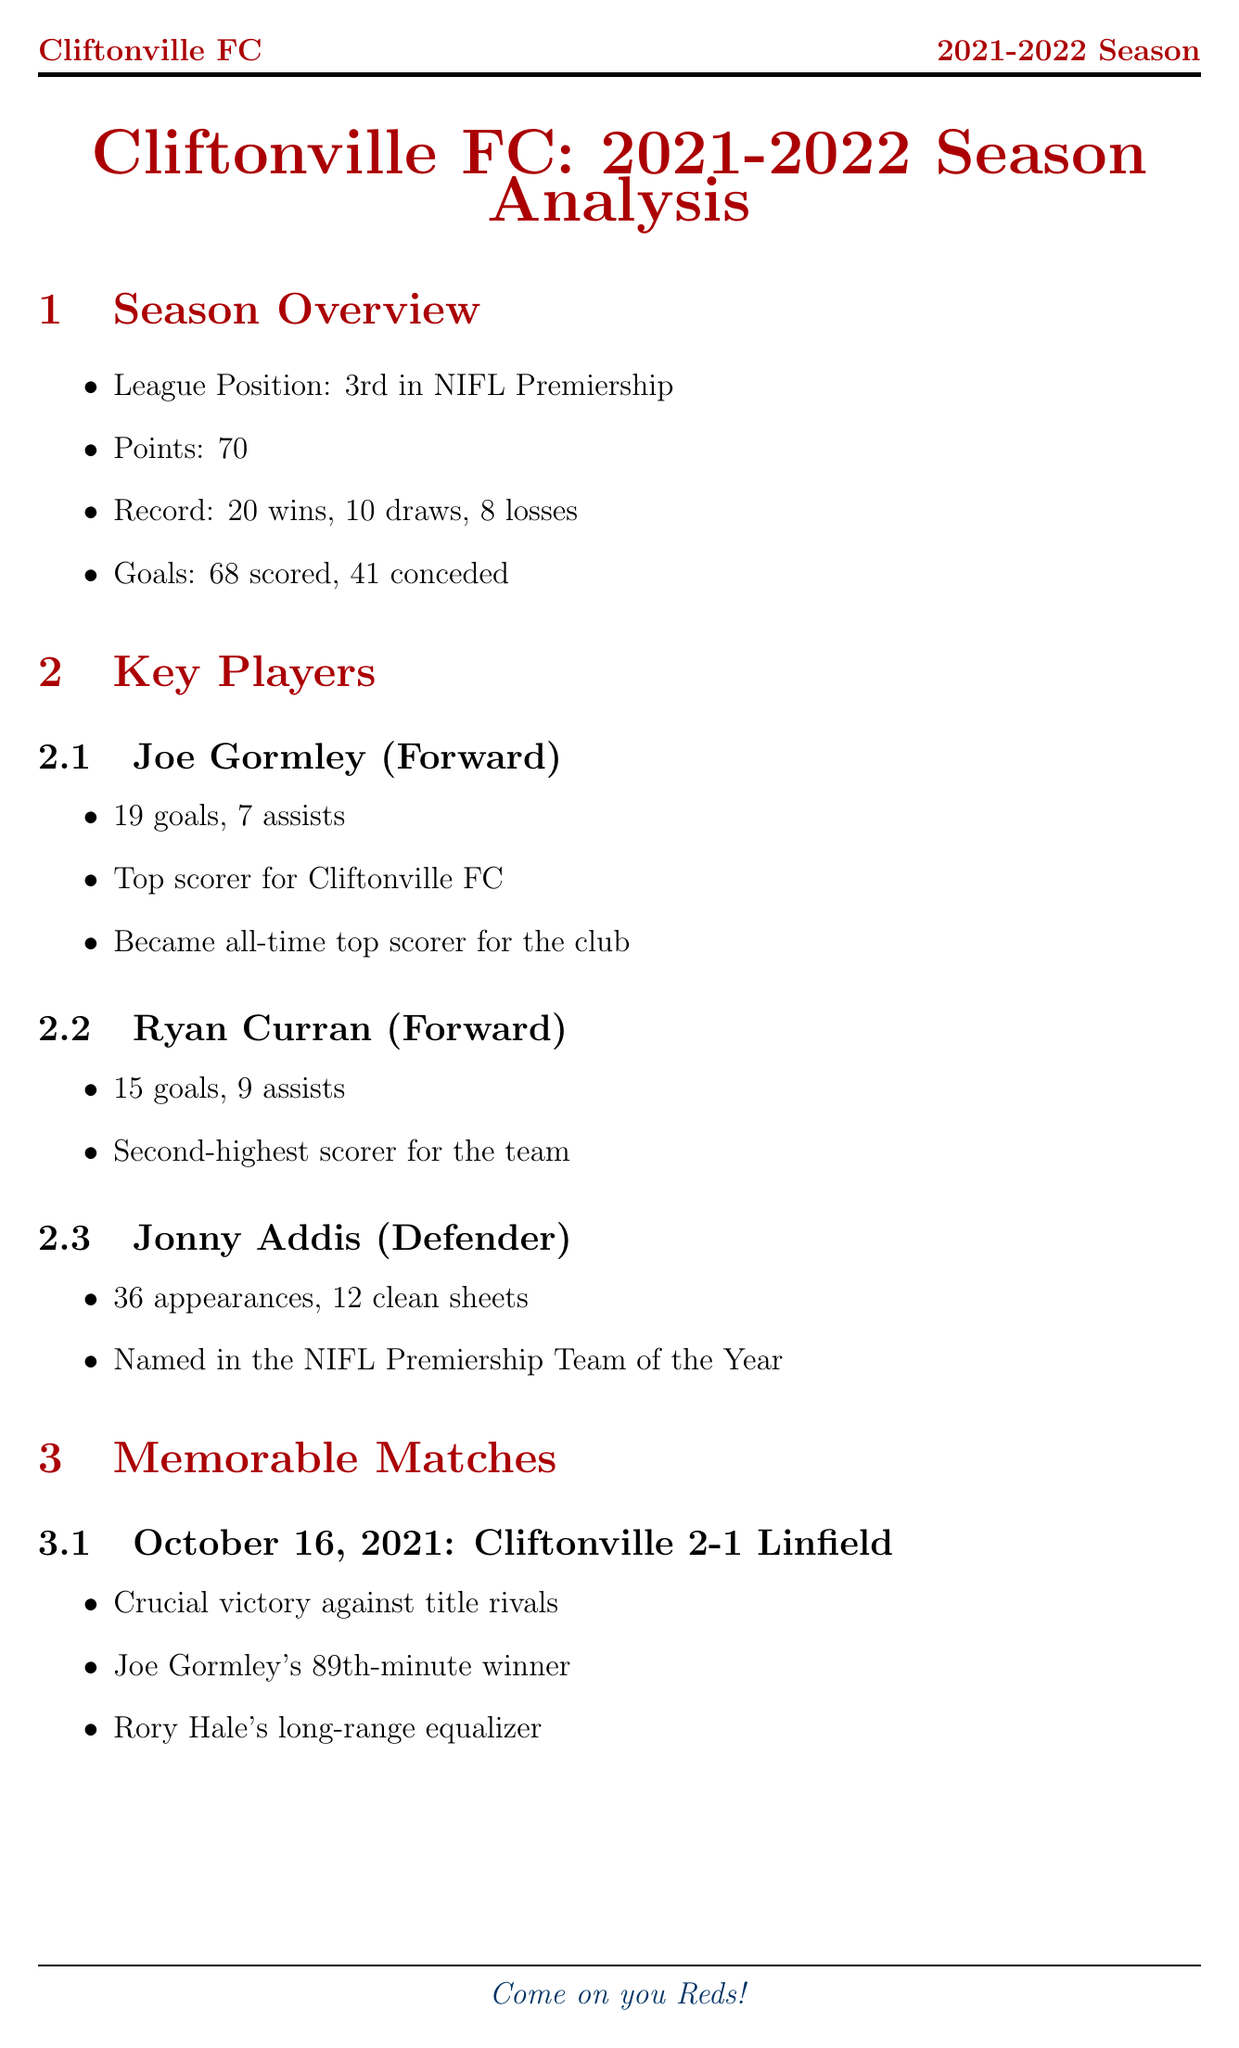What was Cliftonville FC's league position in the 2021-2022 season? The league position is a specific statistic documented in the season overview section.
Answer: 3rd in NIFL Premiership How many goals did Joe Gormley score in the season? This information is provided in the key players section, specifically under Joe Gormley's achievements.
Answer: 19 What date did Cliftonville face Linfield FC? The date of the match is specified in the memorable matches section.
Answer: 2021-10-16 What was the tactical approach used by the manager during the season? The tactical approach is mentioned in the managerial impact section, detailing the strategy employed by the manager.
Answer: Attacking 4-3-3 formation How many points did Cliftonville FC earn during the season? The total points earned is a numerical statistic included in the season overview section.
Answer: 70 What significant historical achievement did Joe Gormley accomplish in this season? This notable achievement is highlighted in the historical context section, summarizing key records.
Answer: Became all-time top scorer for Cliftonville FC Which club was a title rival that Cliftonville defeated in a memorable match? The opponent in a significant match is noted in the memorable matches section.
Answer: Linfield FC How many clean sheets did Jonny Addis achieve during the season? This detail is presented in the key players section under Jonny Addis's accomplishments.
Answer: 12 